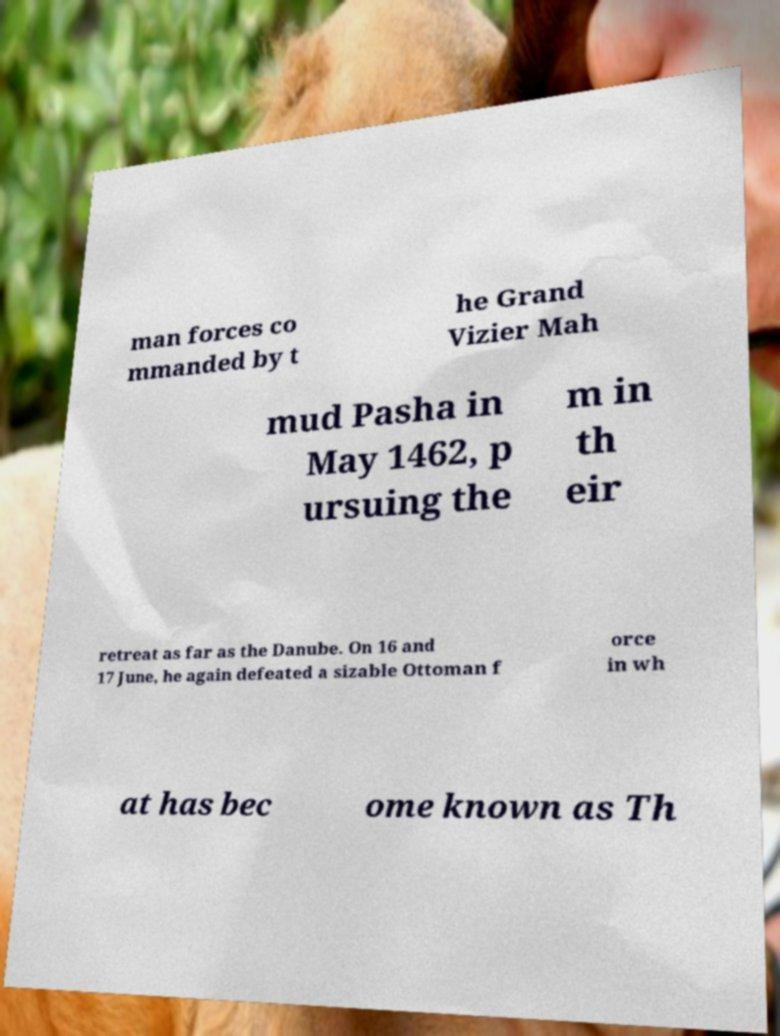What messages or text are displayed in this image? I need them in a readable, typed format. man forces co mmanded by t he Grand Vizier Mah mud Pasha in May 1462, p ursuing the m in th eir retreat as far as the Danube. On 16 and 17 June, he again defeated a sizable Ottoman f orce in wh at has bec ome known as Th 